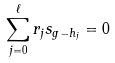Convert formula to latex. <formula><loc_0><loc_0><loc_500><loc_500>\sum _ { j = 0 } ^ { \ell } r _ { j } s _ { g - h _ { j } } = 0</formula> 